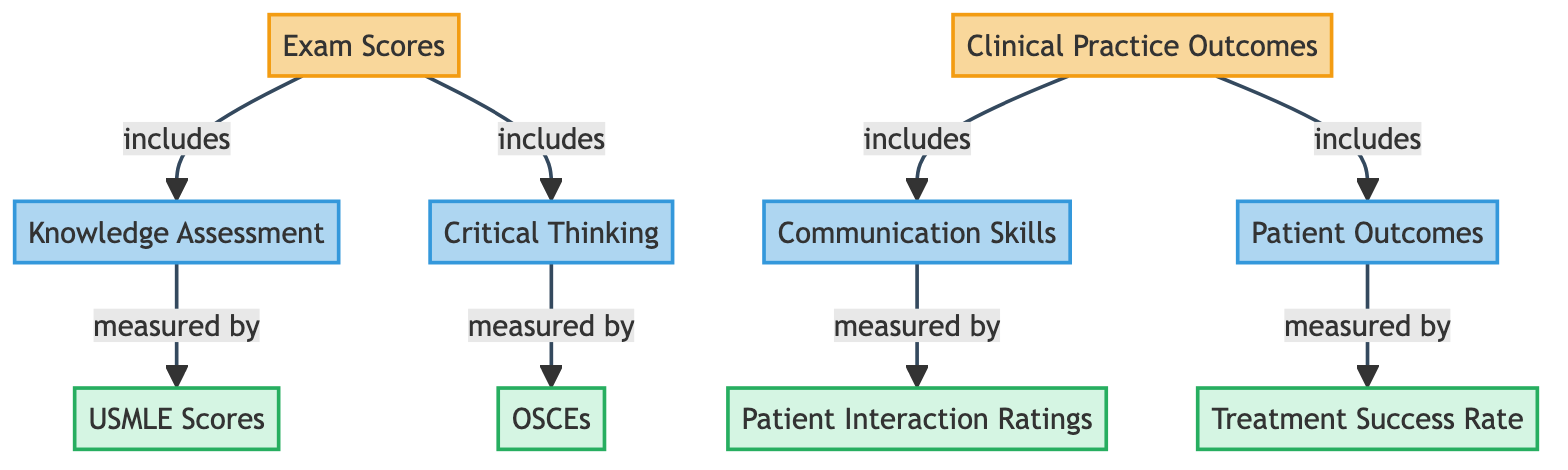What's included under Exam Scores? The diagram shows that Exam Scores includes Knowledge Assessment and Critical Thinking. This is visible from the arrows leading from the Exam Scores node to these two subcategory nodes.
Answer: Knowledge Assessment, Critical Thinking How is Knowledge Assessment measured? According to the diagram, Knowledge Assessment is measured by USMLE Scores, as indicated by the arrow pointing from the Knowledge Assessment node to the USMLE Scores metric node.
Answer: USMLE Scores What two categories does the diagram display? The diagram clearly differentiates between two main categories: Exam Scores and Clinical Practice Outcomes, which are the top-level nodes in the flowchart.
Answer: Exam Scores, Clinical Practice Outcomes Which skills are measured under Clinical Practice? The Clinical Practice Outcomes node includes Communication Skills and Patient Outcomes, which can be traced from the arrows leading from Clinical Practice to these subcategory nodes.
Answer: Communication Skills, Patient Outcomes What is the relationship between Critical Thinking and OSCEs? The diagram indicates that Critical Thinking is measured by Objective Structured Clinical Exams (OSCEs), shown by the arrow from the Critical Thinking node directly to the OSCEs metric node.
Answer: Measured by OSCEs How many metrics are listed under Clinical Practice Outcomes? There are two metrics indicated in the diagram under Clinical Practice Outcomes: Patient Interaction Ratings and Treatment Success Rate, confirmed by the two arrows from the patient outcomes and communication skills subcategory nodes to these metric nodes.
Answer: Two metrics Which metric evaluates patient outcomes? The Treatment Success Rate node is highlighted as the metric that measures Patient Outcomes, clearly denoted by the arrow from the Patient Outcomes node to Treatment Success Rate.
Answer: Treatment Success Rate How many subcategories are under Exam Scores? The diagram presents two subcategories under Exam Scores, specifically Knowledge Assessment and Critical Thinking, as represented by the connections leading to these nodes from Exam Scores.
Answer: Two subcategories What are the two main components of Clinical Practice Outcomes? According to the diagram, Clinical Practice Outcomes consists of Communication Skills and Patient Outcomes, identifiable by the direct links from the Clinical Practice node to these subcategory nodes.
Answer: Communication Skills, Patient Outcomes 